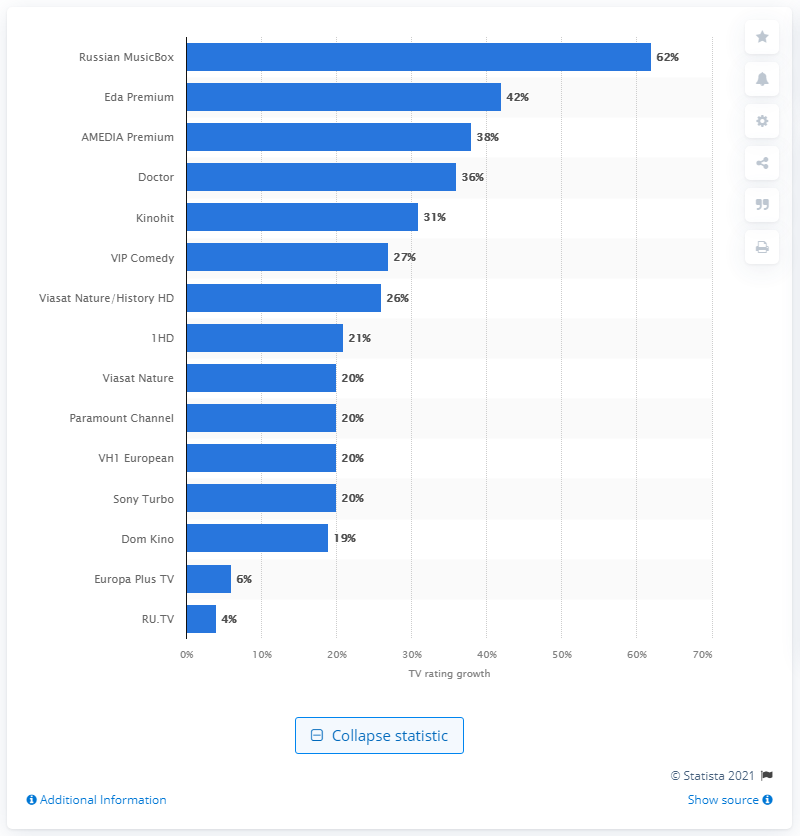Point out several critical features in this image. On March 16 to March 22, 2020, the cooking channel Eda Premium grew by 42 percent in Moscow. 